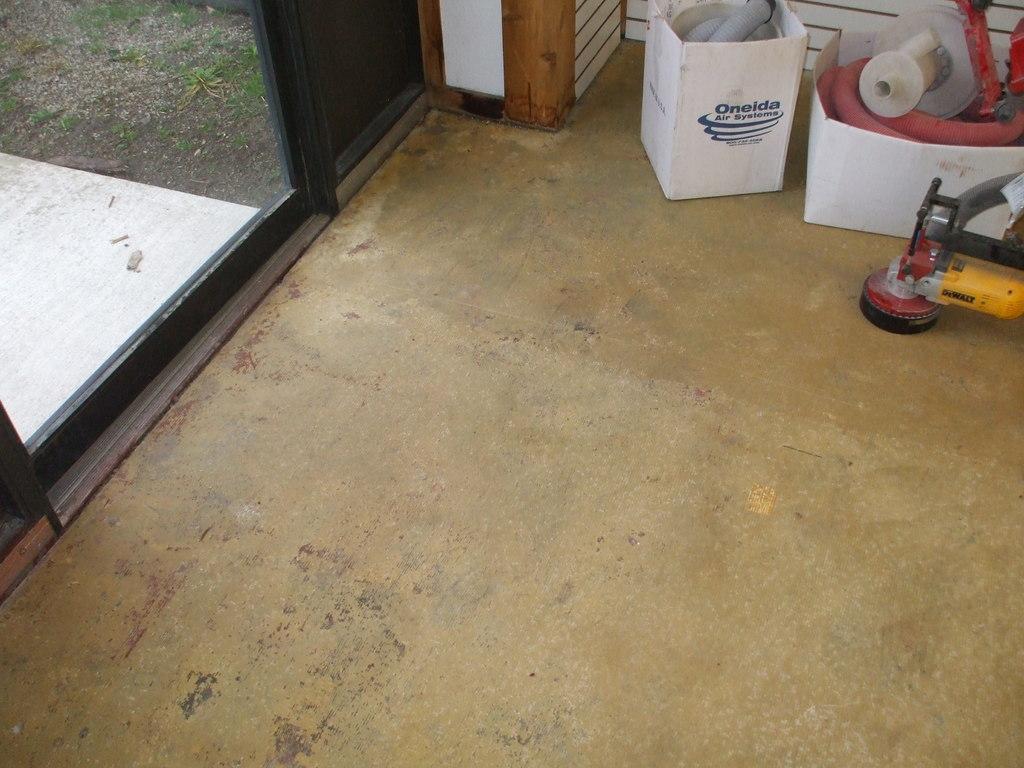Can you describe this image briefly? In this image we can see one object on the floor looks like a machine, some text on the box, two objects looks like the pipes in the white boxes near the wall, one object in the box on the right side of the image, one white object on the ground near the black door and some grass on the ground. 